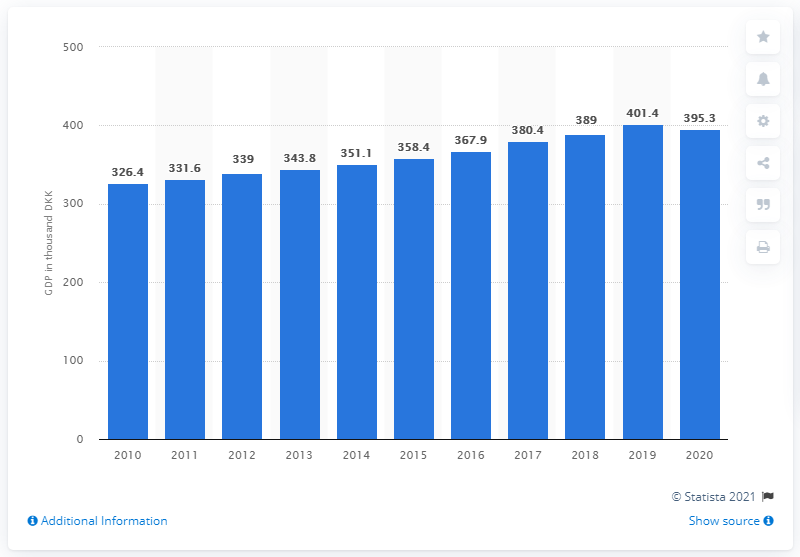List a handful of essential elements in this visual. In the year 2010, there were 395.3 Danish kroner. 